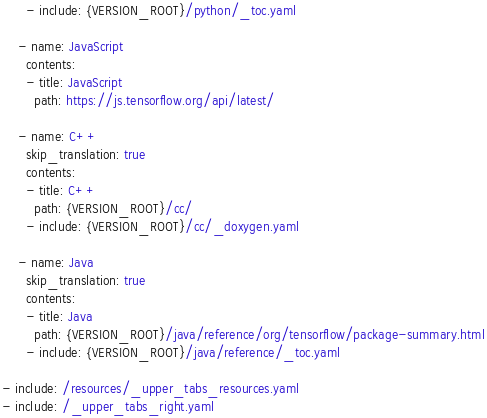Convert code to text. <code><loc_0><loc_0><loc_500><loc_500><_YAML_>      - include: {VERSION_ROOT}/python/_toc.yaml

    - name: JavaScript
      contents:
      - title: JavaScript
        path: https://js.tensorflow.org/api/latest/

    - name: C++
      skip_translation: true
      contents:
      - title: C++
        path: {VERSION_ROOT}/cc/
      - include: {VERSION_ROOT}/cc/_doxygen.yaml

    - name: Java
      skip_translation: true
      contents:
      - title: Java
        path: {VERSION_ROOT}/java/reference/org/tensorflow/package-summary.html
      - include: {VERSION_ROOT}/java/reference/_toc.yaml

- include: /resources/_upper_tabs_resources.yaml
- include: /_upper_tabs_right.yaml
</code> 